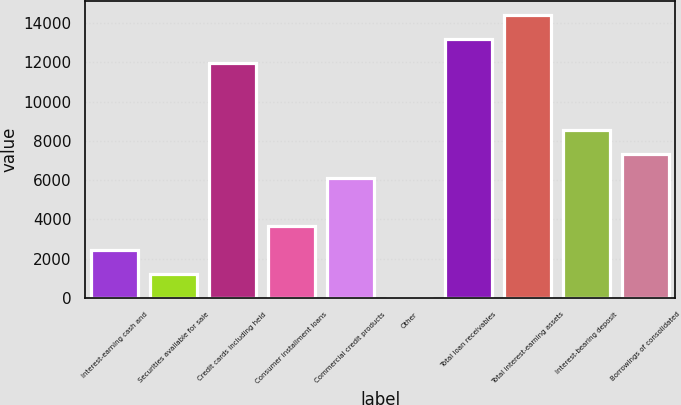<chart> <loc_0><loc_0><loc_500><loc_500><bar_chart><fcel>Interest-earning cash and<fcel>Securities available for sale<fcel>Credit cards including held<fcel>Consumer installment loans<fcel>Commercial credit products<fcel>Other<fcel>Total loan receivables<fcel>Total interest-earning assets<fcel>Interest-bearing deposit<fcel>Borrowings of consolidated<nl><fcel>2449.2<fcel>1225.1<fcel>11967<fcel>3673.3<fcel>6121.5<fcel>1<fcel>13191.1<fcel>14415.2<fcel>8569.7<fcel>7345.6<nl></chart> 